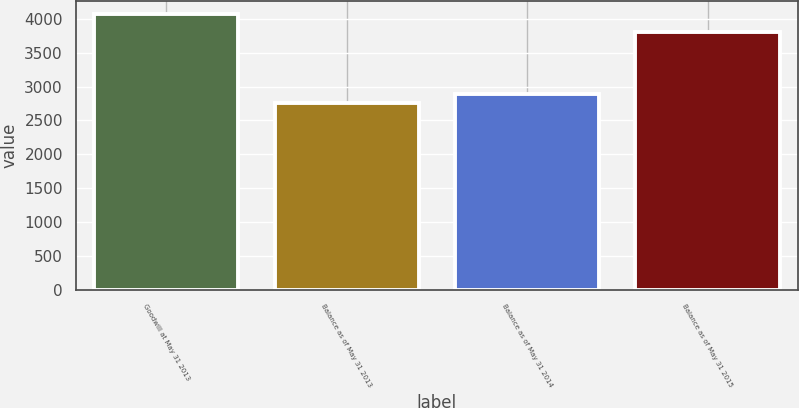Convert chart. <chart><loc_0><loc_0><loc_500><loc_500><bar_chart><fcel>Goodwill at May 31 2013<fcel>Balance as of May 31 2013<fcel>Balance as of May 31 2014<fcel>Balance as of May 31 2015<nl><fcel>4065<fcel>2755<fcel>2886<fcel>3810<nl></chart> 